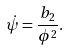Convert formula to latex. <formula><loc_0><loc_0><loc_500><loc_500>\dot { \psi } = \frac { b _ { 2 } } { \phi ^ { 2 } } .</formula> 